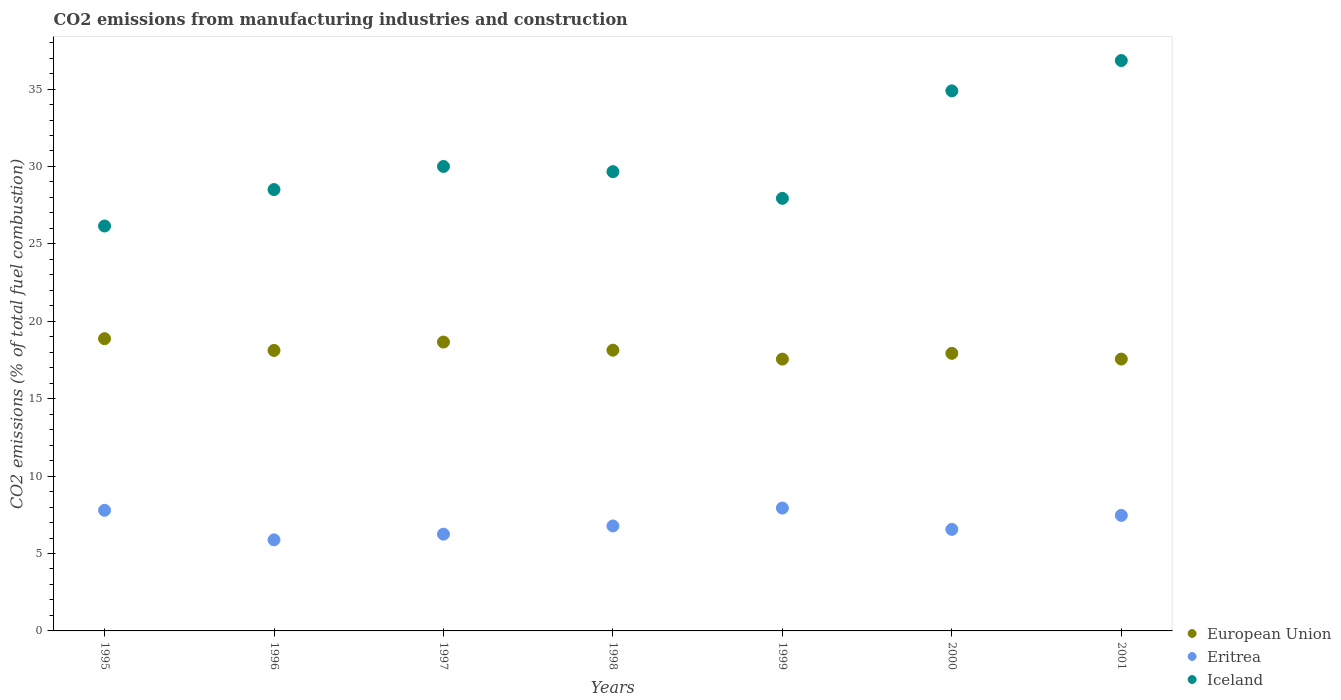Is the number of dotlines equal to the number of legend labels?
Provide a succinct answer. Yes. What is the amount of CO2 emitted in Iceland in 1998?
Make the answer very short. 29.67. Across all years, what is the maximum amount of CO2 emitted in Eritrea?
Keep it short and to the point. 7.94. Across all years, what is the minimum amount of CO2 emitted in European Union?
Your response must be concise. 17.56. In which year was the amount of CO2 emitted in European Union maximum?
Keep it short and to the point. 1995. What is the total amount of CO2 emitted in Iceland in the graph?
Make the answer very short. 213.99. What is the difference between the amount of CO2 emitted in European Union in 1995 and that in 1998?
Ensure brevity in your answer.  0.74. What is the difference between the amount of CO2 emitted in Eritrea in 1995 and the amount of CO2 emitted in Iceland in 2000?
Your answer should be compact. -27.09. What is the average amount of CO2 emitted in Iceland per year?
Keep it short and to the point. 30.57. In the year 1999, what is the difference between the amount of CO2 emitted in European Union and amount of CO2 emitted in Eritrea?
Make the answer very short. 9.62. What is the ratio of the amount of CO2 emitted in European Union in 1997 to that in 2000?
Offer a terse response. 1.04. Is the amount of CO2 emitted in Eritrea in 1997 less than that in 1999?
Offer a terse response. Yes. Is the difference between the amount of CO2 emitted in European Union in 1999 and 2000 greater than the difference between the amount of CO2 emitted in Eritrea in 1999 and 2000?
Keep it short and to the point. No. What is the difference between the highest and the second highest amount of CO2 emitted in Iceland?
Your answer should be very brief. 1.96. What is the difference between the highest and the lowest amount of CO2 emitted in Eritrea?
Ensure brevity in your answer.  2.05. In how many years, is the amount of CO2 emitted in European Union greater than the average amount of CO2 emitted in European Union taken over all years?
Ensure brevity in your answer.  3. Is the sum of the amount of CO2 emitted in Iceland in 1995 and 1998 greater than the maximum amount of CO2 emitted in Eritrea across all years?
Give a very brief answer. Yes. Is the amount of CO2 emitted in European Union strictly greater than the amount of CO2 emitted in Iceland over the years?
Your response must be concise. No. Is the amount of CO2 emitted in Eritrea strictly less than the amount of CO2 emitted in European Union over the years?
Your answer should be compact. Yes. Does the graph contain any zero values?
Give a very brief answer. No. Does the graph contain grids?
Provide a succinct answer. No. What is the title of the graph?
Provide a short and direct response. CO2 emissions from manufacturing industries and construction. What is the label or title of the Y-axis?
Give a very brief answer. CO2 emissions (% of total fuel combustion). What is the CO2 emissions (% of total fuel combustion) in European Union in 1995?
Provide a short and direct response. 18.88. What is the CO2 emissions (% of total fuel combustion) in Eritrea in 1995?
Give a very brief answer. 7.79. What is the CO2 emissions (% of total fuel combustion) in Iceland in 1995?
Give a very brief answer. 26.15. What is the CO2 emissions (% of total fuel combustion) in European Union in 1996?
Ensure brevity in your answer.  18.12. What is the CO2 emissions (% of total fuel combustion) of Eritrea in 1996?
Provide a short and direct response. 5.88. What is the CO2 emissions (% of total fuel combustion) of Iceland in 1996?
Provide a succinct answer. 28.51. What is the CO2 emissions (% of total fuel combustion) in European Union in 1997?
Provide a short and direct response. 18.66. What is the CO2 emissions (% of total fuel combustion) in Eritrea in 1997?
Offer a terse response. 6.25. What is the CO2 emissions (% of total fuel combustion) of Iceland in 1997?
Provide a short and direct response. 30. What is the CO2 emissions (% of total fuel combustion) in European Union in 1998?
Make the answer very short. 18.13. What is the CO2 emissions (% of total fuel combustion) of Eritrea in 1998?
Your answer should be compact. 6.78. What is the CO2 emissions (% of total fuel combustion) in Iceland in 1998?
Offer a very short reply. 29.67. What is the CO2 emissions (% of total fuel combustion) of European Union in 1999?
Provide a succinct answer. 17.56. What is the CO2 emissions (% of total fuel combustion) in Eritrea in 1999?
Keep it short and to the point. 7.94. What is the CO2 emissions (% of total fuel combustion) of Iceland in 1999?
Ensure brevity in your answer.  27.94. What is the CO2 emissions (% of total fuel combustion) in European Union in 2000?
Give a very brief answer. 17.93. What is the CO2 emissions (% of total fuel combustion) of Eritrea in 2000?
Ensure brevity in your answer.  6.56. What is the CO2 emissions (% of total fuel combustion) in Iceland in 2000?
Provide a succinct answer. 34.88. What is the CO2 emissions (% of total fuel combustion) of European Union in 2001?
Your answer should be compact. 17.56. What is the CO2 emissions (% of total fuel combustion) in Eritrea in 2001?
Provide a succinct answer. 7.46. What is the CO2 emissions (% of total fuel combustion) in Iceland in 2001?
Keep it short and to the point. 36.84. Across all years, what is the maximum CO2 emissions (% of total fuel combustion) in European Union?
Provide a succinct answer. 18.88. Across all years, what is the maximum CO2 emissions (% of total fuel combustion) in Eritrea?
Give a very brief answer. 7.94. Across all years, what is the maximum CO2 emissions (% of total fuel combustion) of Iceland?
Provide a succinct answer. 36.84. Across all years, what is the minimum CO2 emissions (% of total fuel combustion) of European Union?
Give a very brief answer. 17.56. Across all years, what is the minimum CO2 emissions (% of total fuel combustion) in Eritrea?
Offer a terse response. 5.88. Across all years, what is the minimum CO2 emissions (% of total fuel combustion) of Iceland?
Keep it short and to the point. 26.15. What is the total CO2 emissions (% of total fuel combustion) of European Union in the graph?
Your answer should be compact. 126.83. What is the total CO2 emissions (% of total fuel combustion) of Eritrea in the graph?
Offer a terse response. 48.66. What is the total CO2 emissions (% of total fuel combustion) in Iceland in the graph?
Your response must be concise. 213.99. What is the difference between the CO2 emissions (% of total fuel combustion) of European Union in 1995 and that in 1996?
Make the answer very short. 0.76. What is the difference between the CO2 emissions (% of total fuel combustion) of Eritrea in 1995 and that in 1996?
Your response must be concise. 1.91. What is the difference between the CO2 emissions (% of total fuel combustion) in Iceland in 1995 and that in 1996?
Your answer should be very brief. -2.35. What is the difference between the CO2 emissions (% of total fuel combustion) of European Union in 1995 and that in 1997?
Ensure brevity in your answer.  0.22. What is the difference between the CO2 emissions (% of total fuel combustion) of Eritrea in 1995 and that in 1997?
Ensure brevity in your answer.  1.54. What is the difference between the CO2 emissions (% of total fuel combustion) of Iceland in 1995 and that in 1997?
Provide a short and direct response. -3.85. What is the difference between the CO2 emissions (% of total fuel combustion) of European Union in 1995 and that in 1998?
Provide a short and direct response. 0.74. What is the difference between the CO2 emissions (% of total fuel combustion) in Eritrea in 1995 and that in 1998?
Provide a succinct answer. 1.01. What is the difference between the CO2 emissions (% of total fuel combustion) of Iceland in 1995 and that in 1998?
Give a very brief answer. -3.51. What is the difference between the CO2 emissions (% of total fuel combustion) of European Union in 1995 and that in 1999?
Provide a short and direct response. 1.32. What is the difference between the CO2 emissions (% of total fuel combustion) of Eritrea in 1995 and that in 1999?
Ensure brevity in your answer.  -0.14. What is the difference between the CO2 emissions (% of total fuel combustion) of Iceland in 1995 and that in 1999?
Your answer should be very brief. -1.79. What is the difference between the CO2 emissions (% of total fuel combustion) of European Union in 1995 and that in 2000?
Offer a very short reply. 0.95. What is the difference between the CO2 emissions (% of total fuel combustion) of Eritrea in 1995 and that in 2000?
Keep it short and to the point. 1.23. What is the difference between the CO2 emissions (% of total fuel combustion) of Iceland in 1995 and that in 2000?
Offer a terse response. -8.73. What is the difference between the CO2 emissions (% of total fuel combustion) in European Union in 1995 and that in 2001?
Your answer should be compact. 1.32. What is the difference between the CO2 emissions (% of total fuel combustion) of Eritrea in 1995 and that in 2001?
Your answer should be very brief. 0.33. What is the difference between the CO2 emissions (% of total fuel combustion) of Iceland in 1995 and that in 2001?
Provide a succinct answer. -10.69. What is the difference between the CO2 emissions (% of total fuel combustion) in European Union in 1996 and that in 1997?
Give a very brief answer. -0.54. What is the difference between the CO2 emissions (% of total fuel combustion) in Eritrea in 1996 and that in 1997?
Provide a short and direct response. -0.37. What is the difference between the CO2 emissions (% of total fuel combustion) of Iceland in 1996 and that in 1997?
Offer a very short reply. -1.49. What is the difference between the CO2 emissions (% of total fuel combustion) in European Union in 1996 and that in 1998?
Your response must be concise. -0.02. What is the difference between the CO2 emissions (% of total fuel combustion) of Eritrea in 1996 and that in 1998?
Provide a short and direct response. -0.9. What is the difference between the CO2 emissions (% of total fuel combustion) in Iceland in 1996 and that in 1998?
Your response must be concise. -1.16. What is the difference between the CO2 emissions (% of total fuel combustion) in European Union in 1996 and that in 1999?
Provide a short and direct response. 0.56. What is the difference between the CO2 emissions (% of total fuel combustion) in Eritrea in 1996 and that in 1999?
Offer a very short reply. -2.05. What is the difference between the CO2 emissions (% of total fuel combustion) in Iceland in 1996 and that in 1999?
Offer a terse response. 0.57. What is the difference between the CO2 emissions (% of total fuel combustion) in European Union in 1996 and that in 2000?
Give a very brief answer. 0.19. What is the difference between the CO2 emissions (% of total fuel combustion) of Eritrea in 1996 and that in 2000?
Give a very brief answer. -0.68. What is the difference between the CO2 emissions (% of total fuel combustion) in Iceland in 1996 and that in 2000?
Keep it short and to the point. -6.38. What is the difference between the CO2 emissions (% of total fuel combustion) in European Union in 1996 and that in 2001?
Ensure brevity in your answer.  0.56. What is the difference between the CO2 emissions (% of total fuel combustion) in Eritrea in 1996 and that in 2001?
Give a very brief answer. -1.58. What is the difference between the CO2 emissions (% of total fuel combustion) in Iceland in 1996 and that in 2001?
Provide a short and direct response. -8.34. What is the difference between the CO2 emissions (% of total fuel combustion) of European Union in 1997 and that in 1998?
Provide a succinct answer. 0.52. What is the difference between the CO2 emissions (% of total fuel combustion) in Eritrea in 1997 and that in 1998?
Offer a very short reply. -0.53. What is the difference between the CO2 emissions (% of total fuel combustion) of Iceland in 1997 and that in 1998?
Your response must be concise. 0.33. What is the difference between the CO2 emissions (% of total fuel combustion) of European Union in 1997 and that in 1999?
Ensure brevity in your answer.  1.1. What is the difference between the CO2 emissions (% of total fuel combustion) of Eritrea in 1997 and that in 1999?
Keep it short and to the point. -1.69. What is the difference between the CO2 emissions (% of total fuel combustion) in Iceland in 1997 and that in 1999?
Keep it short and to the point. 2.06. What is the difference between the CO2 emissions (% of total fuel combustion) of European Union in 1997 and that in 2000?
Make the answer very short. 0.73. What is the difference between the CO2 emissions (% of total fuel combustion) of Eritrea in 1997 and that in 2000?
Provide a succinct answer. -0.31. What is the difference between the CO2 emissions (% of total fuel combustion) in Iceland in 1997 and that in 2000?
Provide a succinct answer. -4.88. What is the difference between the CO2 emissions (% of total fuel combustion) in European Union in 1997 and that in 2001?
Ensure brevity in your answer.  1.1. What is the difference between the CO2 emissions (% of total fuel combustion) in Eritrea in 1997 and that in 2001?
Make the answer very short. -1.21. What is the difference between the CO2 emissions (% of total fuel combustion) of Iceland in 1997 and that in 2001?
Keep it short and to the point. -6.84. What is the difference between the CO2 emissions (% of total fuel combustion) in European Union in 1998 and that in 1999?
Keep it short and to the point. 0.58. What is the difference between the CO2 emissions (% of total fuel combustion) of Eritrea in 1998 and that in 1999?
Provide a short and direct response. -1.16. What is the difference between the CO2 emissions (% of total fuel combustion) in Iceland in 1998 and that in 1999?
Provide a short and direct response. 1.72. What is the difference between the CO2 emissions (% of total fuel combustion) in European Union in 1998 and that in 2000?
Your answer should be compact. 0.2. What is the difference between the CO2 emissions (% of total fuel combustion) of Eritrea in 1998 and that in 2000?
Your answer should be compact. 0.22. What is the difference between the CO2 emissions (% of total fuel combustion) in Iceland in 1998 and that in 2000?
Provide a short and direct response. -5.22. What is the difference between the CO2 emissions (% of total fuel combustion) in European Union in 1998 and that in 2001?
Your response must be concise. 0.57. What is the difference between the CO2 emissions (% of total fuel combustion) of Eritrea in 1998 and that in 2001?
Provide a succinct answer. -0.68. What is the difference between the CO2 emissions (% of total fuel combustion) of Iceland in 1998 and that in 2001?
Your answer should be compact. -7.18. What is the difference between the CO2 emissions (% of total fuel combustion) in European Union in 1999 and that in 2000?
Offer a very short reply. -0.37. What is the difference between the CO2 emissions (% of total fuel combustion) of Eritrea in 1999 and that in 2000?
Ensure brevity in your answer.  1.38. What is the difference between the CO2 emissions (% of total fuel combustion) of Iceland in 1999 and that in 2000?
Keep it short and to the point. -6.94. What is the difference between the CO2 emissions (% of total fuel combustion) in European Union in 1999 and that in 2001?
Keep it short and to the point. -0. What is the difference between the CO2 emissions (% of total fuel combustion) of Eritrea in 1999 and that in 2001?
Ensure brevity in your answer.  0.47. What is the difference between the CO2 emissions (% of total fuel combustion) in Iceland in 1999 and that in 2001?
Your response must be concise. -8.9. What is the difference between the CO2 emissions (% of total fuel combustion) in European Union in 2000 and that in 2001?
Make the answer very short. 0.37. What is the difference between the CO2 emissions (% of total fuel combustion) in Eritrea in 2000 and that in 2001?
Make the answer very short. -0.91. What is the difference between the CO2 emissions (% of total fuel combustion) in Iceland in 2000 and that in 2001?
Give a very brief answer. -1.96. What is the difference between the CO2 emissions (% of total fuel combustion) in European Union in 1995 and the CO2 emissions (% of total fuel combustion) in Eritrea in 1996?
Your answer should be very brief. 12.99. What is the difference between the CO2 emissions (% of total fuel combustion) in European Union in 1995 and the CO2 emissions (% of total fuel combustion) in Iceland in 1996?
Offer a very short reply. -9.63. What is the difference between the CO2 emissions (% of total fuel combustion) in Eritrea in 1995 and the CO2 emissions (% of total fuel combustion) in Iceland in 1996?
Offer a very short reply. -20.71. What is the difference between the CO2 emissions (% of total fuel combustion) in European Union in 1995 and the CO2 emissions (% of total fuel combustion) in Eritrea in 1997?
Provide a short and direct response. 12.63. What is the difference between the CO2 emissions (% of total fuel combustion) in European Union in 1995 and the CO2 emissions (% of total fuel combustion) in Iceland in 1997?
Provide a succinct answer. -11.12. What is the difference between the CO2 emissions (% of total fuel combustion) in Eritrea in 1995 and the CO2 emissions (% of total fuel combustion) in Iceland in 1997?
Offer a terse response. -22.21. What is the difference between the CO2 emissions (% of total fuel combustion) in European Union in 1995 and the CO2 emissions (% of total fuel combustion) in Eritrea in 1998?
Ensure brevity in your answer.  12.1. What is the difference between the CO2 emissions (% of total fuel combustion) of European Union in 1995 and the CO2 emissions (% of total fuel combustion) of Iceland in 1998?
Offer a terse response. -10.79. What is the difference between the CO2 emissions (% of total fuel combustion) in Eritrea in 1995 and the CO2 emissions (% of total fuel combustion) in Iceland in 1998?
Offer a very short reply. -21.87. What is the difference between the CO2 emissions (% of total fuel combustion) in European Union in 1995 and the CO2 emissions (% of total fuel combustion) in Eritrea in 1999?
Your answer should be very brief. 10.94. What is the difference between the CO2 emissions (% of total fuel combustion) of European Union in 1995 and the CO2 emissions (% of total fuel combustion) of Iceland in 1999?
Keep it short and to the point. -9.07. What is the difference between the CO2 emissions (% of total fuel combustion) of Eritrea in 1995 and the CO2 emissions (% of total fuel combustion) of Iceland in 1999?
Ensure brevity in your answer.  -20.15. What is the difference between the CO2 emissions (% of total fuel combustion) in European Union in 1995 and the CO2 emissions (% of total fuel combustion) in Eritrea in 2000?
Your answer should be very brief. 12.32. What is the difference between the CO2 emissions (% of total fuel combustion) in European Union in 1995 and the CO2 emissions (% of total fuel combustion) in Iceland in 2000?
Your answer should be compact. -16.01. What is the difference between the CO2 emissions (% of total fuel combustion) of Eritrea in 1995 and the CO2 emissions (% of total fuel combustion) of Iceland in 2000?
Provide a short and direct response. -27.09. What is the difference between the CO2 emissions (% of total fuel combustion) of European Union in 1995 and the CO2 emissions (% of total fuel combustion) of Eritrea in 2001?
Offer a terse response. 11.41. What is the difference between the CO2 emissions (% of total fuel combustion) in European Union in 1995 and the CO2 emissions (% of total fuel combustion) in Iceland in 2001?
Make the answer very short. -17.97. What is the difference between the CO2 emissions (% of total fuel combustion) of Eritrea in 1995 and the CO2 emissions (% of total fuel combustion) of Iceland in 2001?
Offer a terse response. -29.05. What is the difference between the CO2 emissions (% of total fuel combustion) of European Union in 1996 and the CO2 emissions (% of total fuel combustion) of Eritrea in 1997?
Provide a short and direct response. 11.87. What is the difference between the CO2 emissions (% of total fuel combustion) in European Union in 1996 and the CO2 emissions (% of total fuel combustion) in Iceland in 1997?
Keep it short and to the point. -11.88. What is the difference between the CO2 emissions (% of total fuel combustion) of Eritrea in 1996 and the CO2 emissions (% of total fuel combustion) of Iceland in 1997?
Give a very brief answer. -24.12. What is the difference between the CO2 emissions (% of total fuel combustion) in European Union in 1996 and the CO2 emissions (% of total fuel combustion) in Eritrea in 1998?
Provide a short and direct response. 11.34. What is the difference between the CO2 emissions (% of total fuel combustion) in European Union in 1996 and the CO2 emissions (% of total fuel combustion) in Iceland in 1998?
Your answer should be very brief. -11.55. What is the difference between the CO2 emissions (% of total fuel combustion) of Eritrea in 1996 and the CO2 emissions (% of total fuel combustion) of Iceland in 1998?
Your response must be concise. -23.78. What is the difference between the CO2 emissions (% of total fuel combustion) in European Union in 1996 and the CO2 emissions (% of total fuel combustion) in Eritrea in 1999?
Your answer should be compact. 10.18. What is the difference between the CO2 emissions (% of total fuel combustion) in European Union in 1996 and the CO2 emissions (% of total fuel combustion) in Iceland in 1999?
Make the answer very short. -9.82. What is the difference between the CO2 emissions (% of total fuel combustion) of Eritrea in 1996 and the CO2 emissions (% of total fuel combustion) of Iceland in 1999?
Offer a very short reply. -22.06. What is the difference between the CO2 emissions (% of total fuel combustion) of European Union in 1996 and the CO2 emissions (% of total fuel combustion) of Eritrea in 2000?
Keep it short and to the point. 11.56. What is the difference between the CO2 emissions (% of total fuel combustion) of European Union in 1996 and the CO2 emissions (% of total fuel combustion) of Iceland in 2000?
Keep it short and to the point. -16.77. What is the difference between the CO2 emissions (% of total fuel combustion) in Eritrea in 1996 and the CO2 emissions (% of total fuel combustion) in Iceland in 2000?
Make the answer very short. -29. What is the difference between the CO2 emissions (% of total fuel combustion) of European Union in 1996 and the CO2 emissions (% of total fuel combustion) of Eritrea in 2001?
Give a very brief answer. 10.65. What is the difference between the CO2 emissions (% of total fuel combustion) of European Union in 1996 and the CO2 emissions (% of total fuel combustion) of Iceland in 2001?
Keep it short and to the point. -18.73. What is the difference between the CO2 emissions (% of total fuel combustion) in Eritrea in 1996 and the CO2 emissions (% of total fuel combustion) in Iceland in 2001?
Ensure brevity in your answer.  -30.96. What is the difference between the CO2 emissions (% of total fuel combustion) of European Union in 1997 and the CO2 emissions (% of total fuel combustion) of Eritrea in 1998?
Your response must be concise. 11.88. What is the difference between the CO2 emissions (% of total fuel combustion) in European Union in 1997 and the CO2 emissions (% of total fuel combustion) in Iceland in 1998?
Give a very brief answer. -11.01. What is the difference between the CO2 emissions (% of total fuel combustion) of Eritrea in 1997 and the CO2 emissions (% of total fuel combustion) of Iceland in 1998?
Give a very brief answer. -23.42. What is the difference between the CO2 emissions (% of total fuel combustion) of European Union in 1997 and the CO2 emissions (% of total fuel combustion) of Eritrea in 1999?
Your answer should be very brief. 10.72. What is the difference between the CO2 emissions (% of total fuel combustion) in European Union in 1997 and the CO2 emissions (% of total fuel combustion) in Iceland in 1999?
Offer a very short reply. -9.28. What is the difference between the CO2 emissions (% of total fuel combustion) in Eritrea in 1997 and the CO2 emissions (% of total fuel combustion) in Iceland in 1999?
Your answer should be compact. -21.69. What is the difference between the CO2 emissions (% of total fuel combustion) of European Union in 1997 and the CO2 emissions (% of total fuel combustion) of Eritrea in 2000?
Ensure brevity in your answer.  12.1. What is the difference between the CO2 emissions (% of total fuel combustion) in European Union in 1997 and the CO2 emissions (% of total fuel combustion) in Iceland in 2000?
Provide a short and direct response. -16.23. What is the difference between the CO2 emissions (% of total fuel combustion) of Eritrea in 1997 and the CO2 emissions (% of total fuel combustion) of Iceland in 2000?
Offer a very short reply. -28.63. What is the difference between the CO2 emissions (% of total fuel combustion) of European Union in 1997 and the CO2 emissions (% of total fuel combustion) of Eritrea in 2001?
Give a very brief answer. 11.2. What is the difference between the CO2 emissions (% of total fuel combustion) in European Union in 1997 and the CO2 emissions (% of total fuel combustion) in Iceland in 2001?
Offer a very short reply. -18.18. What is the difference between the CO2 emissions (% of total fuel combustion) in Eritrea in 1997 and the CO2 emissions (% of total fuel combustion) in Iceland in 2001?
Your response must be concise. -30.59. What is the difference between the CO2 emissions (% of total fuel combustion) of European Union in 1998 and the CO2 emissions (% of total fuel combustion) of Eritrea in 1999?
Your answer should be compact. 10.2. What is the difference between the CO2 emissions (% of total fuel combustion) in European Union in 1998 and the CO2 emissions (% of total fuel combustion) in Iceland in 1999?
Provide a short and direct response. -9.81. What is the difference between the CO2 emissions (% of total fuel combustion) of Eritrea in 1998 and the CO2 emissions (% of total fuel combustion) of Iceland in 1999?
Provide a succinct answer. -21.16. What is the difference between the CO2 emissions (% of total fuel combustion) of European Union in 1998 and the CO2 emissions (% of total fuel combustion) of Eritrea in 2000?
Provide a short and direct response. 11.58. What is the difference between the CO2 emissions (% of total fuel combustion) in European Union in 1998 and the CO2 emissions (% of total fuel combustion) in Iceland in 2000?
Provide a short and direct response. -16.75. What is the difference between the CO2 emissions (% of total fuel combustion) of Eritrea in 1998 and the CO2 emissions (% of total fuel combustion) of Iceland in 2000?
Your response must be concise. -28.1. What is the difference between the CO2 emissions (% of total fuel combustion) in European Union in 1998 and the CO2 emissions (% of total fuel combustion) in Eritrea in 2001?
Keep it short and to the point. 10.67. What is the difference between the CO2 emissions (% of total fuel combustion) of European Union in 1998 and the CO2 emissions (% of total fuel combustion) of Iceland in 2001?
Make the answer very short. -18.71. What is the difference between the CO2 emissions (% of total fuel combustion) of Eritrea in 1998 and the CO2 emissions (% of total fuel combustion) of Iceland in 2001?
Your answer should be compact. -30.06. What is the difference between the CO2 emissions (% of total fuel combustion) of European Union in 1999 and the CO2 emissions (% of total fuel combustion) of Eritrea in 2000?
Your answer should be compact. 11. What is the difference between the CO2 emissions (% of total fuel combustion) in European Union in 1999 and the CO2 emissions (% of total fuel combustion) in Iceland in 2000?
Give a very brief answer. -17.33. What is the difference between the CO2 emissions (% of total fuel combustion) of Eritrea in 1999 and the CO2 emissions (% of total fuel combustion) of Iceland in 2000?
Provide a succinct answer. -26.95. What is the difference between the CO2 emissions (% of total fuel combustion) of European Union in 1999 and the CO2 emissions (% of total fuel combustion) of Eritrea in 2001?
Make the answer very short. 10.09. What is the difference between the CO2 emissions (% of total fuel combustion) of European Union in 1999 and the CO2 emissions (% of total fuel combustion) of Iceland in 2001?
Offer a very short reply. -19.29. What is the difference between the CO2 emissions (% of total fuel combustion) of Eritrea in 1999 and the CO2 emissions (% of total fuel combustion) of Iceland in 2001?
Provide a short and direct response. -28.91. What is the difference between the CO2 emissions (% of total fuel combustion) in European Union in 2000 and the CO2 emissions (% of total fuel combustion) in Eritrea in 2001?
Your answer should be compact. 10.47. What is the difference between the CO2 emissions (% of total fuel combustion) of European Union in 2000 and the CO2 emissions (% of total fuel combustion) of Iceland in 2001?
Your answer should be compact. -18.91. What is the difference between the CO2 emissions (% of total fuel combustion) in Eritrea in 2000 and the CO2 emissions (% of total fuel combustion) in Iceland in 2001?
Keep it short and to the point. -30.28. What is the average CO2 emissions (% of total fuel combustion) of European Union per year?
Give a very brief answer. 18.12. What is the average CO2 emissions (% of total fuel combustion) in Eritrea per year?
Make the answer very short. 6.95. What is the average CO2 emissions (% of total fuel combustion) in Iceland per year?
Give a very brief answer. 30.57. In the year 1995, what is the difference between the CO2 emissions (% of total fuel combustion) in European Union and CO2 emissions (% of total fuel combustion) in Eritrea?
Make the answer very short. 11.08. In the year 1995, what is the difference between the CO2 emissions (% of total fuel combustion) of European Union and CO2 emissions (% of total fuel combustion) of Iceland?
Offer a terse response. -7.28. In the year 1995, what is the difference between the CO2 emissions (% of total fuel combustion) in Eritrea and CO2 emissions (% of total fuel combustion) in Iceland?
Keep it short and to the point. -18.36. In the year 1996, what is the difference between the CO2 emissions (% of total fuel combustion) in European Union and CO2 emissions (% of total fuel combustion) in Eritrea?
Offer a terse response. 12.23. In the year 1996, what is the difference between the CO2 emissions (% of total fuel combustion) of European Union and CO2 emissions (% of total fuel combustion) of Iceland?
Your answer should be very brief. -10.39. In the year 1996, what is the difference between the CO2 emissions (% of total fuel combustion) of Eritrea and CO2 emissions (% of total fuel combustion) of Iceland?
Your response must be concise. -22.62. In the year 1997, what is the difference between the CO2 emissions (% of total fuel combustion) in European Union and CO2 emissions (% of total fuel combustion) in Eritrea?
Keep it short and to the point. 12.41. In the year 1997, what is the difference between the CO2 emissions (% of total fuel combustion) of European Union and CO2 emissions (% of total fuel combustion) of Iceland?
Make the answer very short. -11.34. In the year 1997, what is the difference between the CO2 emissions (% of total fuel combustion) in Eritrea and CO2 emissions (% of total fuel combustion) in Iceland?
Your answer should be very brief. -23.75. In the year 1998, what is the difference between the CO2 emissions (% of total fuel combustion) in European Union and CO2 emissions (% of total fuel combustion) in Eritrea?
Keep it short and to the point. 11.35. In the year 1998, what is the difference between the CO2 emissions (% of total fuel combustion) of European Union and CO2 emissions (% of total fuel combustion) of Iceland?
Keep it short and to the point. -11.53. In the year 1998, what is the difference between the CO2 emissions (% of total fuel combustion) of Eritrea and CO2 emissions (% of total fuel combustion) of Iceland?
Your answer should be compact. -22.89. In the year 1999, what is the difference between the CO2 emissions (% of total fuel combustion) in European Union and CO2 emissions (% of total fuel combustion) in Eritrea?
Provide a succinct answer. 9.62. In the year 1999, what is the difference between the CO2 emissions (% of total fuel combustion) in European Union and CO2 emissions (% of total fuel combustion) in Iceland?
Offer a terse response. -10.39. In the year 1999, what is the difference between the CO2 emissions (% of total fuel combustion) in Eritrea and CO2 emissions (% of total fuel combustion) in Iceland?
Offer a very short reply. -20. In the year 2000, what is the difference between the CO2 emissions (% of total fuel combustion) of European Union and CO2 emissions (% of total fuel combustion) of Eritrea?
Give a very brief answer. 11.37. In the year 2000, what is the difference between the CO2 emissions (% of total fuel combustion) of European Union and CO2 emissions (% of total fuel combustion) of Iceland?
Offer a very short reply. -16.96. In the year 2000, what is the difference between the CO2 emissions (% of total fuel combustion) in Eritrea and CO2 emissions (% of total fuel combustion) in Iceland?
Your response must be concise. -28.33. In the year 2001, what is the difference between the CO2 emissions (% of total fuel combustion) of European Union and CO2 emissions (% of total fuel combustion) of Eritrea?
Make the answer very short. 10.1. In the year 2001, what is the difference between the CO2 emissions (% of total fuel combustion) of European Union and CO2 emissions (% of total fuel combustion) of Iceland?
Your answer should be compact. -19.28. In the year 2001, what is the difference between the CO2 emissions (% of total fuel combustion) of Eritrea and CO2 emissions (% of total fuel combustion) of Iceland?
Keep it short and to the point. -29.38. What is the ratio of the CO2 emissions (% of total fuel combustion) in European Union in 1995 to that in 1996?
Give a very brief answer. 1.04. What is the ratio of the CO2 emissions (% of total fuel combustion) in Eritrea in 1995 to that in 1996?
Keep it short and to the point. 1.32. What is the ratio of the CO2 emissions (% of total fuel combustion) of Iceland in 1995 to that in 1996?
Keep it short and to the point. 0.92. What is the ratio of the CO2 emissions (% of total fuel combustion) in European Union in 1995 to that in 1997?
Your answer should be very brief. 1.01. What is the ratio of the CO2 emissions (% of total fuel combustion) in Eritrea in 1995 to that in 1997?
Offer a very short reply. 1.25. What is the ratio of the CO2 emissions (% of total fuel combustion) of Iceland in 1995 to that in 1997?
Keep it short and to the point. 0.87. What is the ratio of the CO2 emissions (% of total fuel combustion) in European Union in 1995 to that in 1998?
Provide a short and direct response. 1.04. What is the ratio of the CO2 emissions (% of total fuel combustion) of Eritrea in 1995 to that in 1998?
Provide a short and direct response. 1.15. What is the ratio of the CO2 emissions (% of total fuel combustion) in Iceland in 1995 to that in 1998?
Give a very brief answer. 0.88. What is the ratio of the CO2 emissions (% of total fuel combustion) of European Union in 1995 to that in 1999?
Your response must be concise. 1.08. What is the ratio of the CO2 emissions (% of total fuel combustion) of Eritrea in 1995 to that in 1999?
Ensure brevity in your answer.  0.98. What is the ratio of the CO2 emissions (% of total fuel combustion) in Iceland in 1995 to that in 1999?
Make the answer very short. 0.94. What is the ratio of the CO2 emissions (% of total fuel combustion) in European Union in 1995 to that in 2000?
Offer a very short reply. 1.05. What is the ratio of the CO2 emissions (% of total fuel combustion) in Eritrea in 1995 to that in 2000?
Offer a terse response. 1.19. What is the ratio of the CO2 emissions (% of total fuel combustion) in Iceland in 1995 to that in 2000?
Provide a succinct answer. 0.75. What is the ratio of the CO2 emissions (% of total fuel combustion) of European Union in 1995 to that in 2001?
Your answer should be very brief. 1.07. What is the ratio of the CO2 emissions (% of total fuel combustion) in Eritrea in 1995 to that in 2001?
Your answer should be compact. 1.04. What is the ratio of the CO2 emissions (% of total fuel combustion) in Iceland in 1995 to that in 2001?
Provide a succinct answer. 0.71. What is the ratio of the CO2 emissions (% of total fuel combustion) of Iceland in 1996 to that in 1997?
Provide a succinct answer. 0.95. What is the ratio of the CO2 emissions (% of total fuel combustion) in European Union in 1996 to that in 1998?
Ensure brevity in your answer.  1. What is the ratio of the CO2 emissions (% of total fuel combustion) in Eritrea in 1996 to that in 1998?
Ensure brevity in your answer.  0.87. What is the ratio of the CO2 emissions (% of total fuel combustion) in European Union in 1996 to that in 1999?
Offer a terse response. 1.03. What is the ratio of the CO2 emissions (% of total fuel combustion) of Eritrea in 1996 to that in 1999?
Ensure brevity in your answer.  0.74. What is the ratio of the CO2 emissions (% of total fuel combustion) of Iceland in 1996 to that in 1999?
Keep it short and to the point. 1.02. What is the ratio of the CO2 emissions (% of total fuel combustion) in European Union in 1996 to that in 2000?
Your response must be concise. 1.01. What is the ratio of the CO2 emissions (% of total fuel combustion) of Eritrea in 1996 to that in 2000?
Your answer should be compact. 0.9. What is the ratio of the CO2 emissions (% of total fuel combustion) in Iceland in 1996 to that in 2000?
Give a very brief answer. 0.82. What is the ratio of the CO2 emissions (% of total fuel combustion) of European Union in 1996 to that in 2001?
Ensure brevity in your answer.  1.03. What is the ratio of the CO2 emissions (% of total fuel combustion) of Eritrea in 1996 to that in 2001?
Provide a short and direct response. 0.79. What is the ratio of the CO2 emissions (% of total fuel combustion) in Iceland in 1996 to that in 2001?
Your answer should be very brief. 0.77. What is the ratio of the CO2 emissions (% of total fuel combustion) in European Union in 1997 to that in 1998?
Keep it short and to the point. 1.03. What is the ratio of the CO2 emissions (% of total fuel combustion) in Eritrea in 1997 to that in 1998?
Your response must be concise. 0.92. What is the ratio of the CO2 emissions (% of total fuel combustion) of Iceland in 1997 to that in 1998?
Give a very brief answer. 1.01. What is the ratio of the CO2 emissions (% of total fuel combustion) of European Union in 1997 to that in 1999?
Offer a very short reply. 1.06. What is the ratio of the CO2 emissions (% of total fuel combustion) of Eritrea in 1997 to that in 1999?
Make the answer very short. 0.79. What is the ratio of the CO2 emissions (% of total fuel combustion) in Iceland in 1997 to that in 1999?
Keep it short and to the point. 1.07. What is the ratio of the CO2 emissions (% of total fuel combustion) in European Union in 1997 to that in 2000?
Make the answer very short. 1.04. What is the ratio of the CO2 emissions (% of total fuel combustion) of Eritrea in 1997 to that in 2000?
Provide a short and direct response. 0.95. What is the ratio of the CO2 emissions (% of total fuel combustion) in Iceland in 1997 to that in 2000?
Your answer should be very brief. 0.86. What is the ratio of the CO2 emissions (% of total fuel combustion) of European Union in 1997 to that in 2001?
Your response must be concise. 1.06. What is the ratio of the CO2 emissions (% of total fuel combustion) of Eritrea in 1997 to that in 2001?
Offer a terse response. 0.84. What is the ratio of the CO2 emissions (% of total fuel combustion) of Iceland in 1997 to that in 2001?
Your answer should be compact. 0.81. What is the ratio of the CO2 emissions (% of total fuel combustion) of European Union in 1998 to that in 1999?
Your answer should be compact. 1.03. What is the ratio of the CO2 emissions (% of total fuel combustion) of Eritrea in 1998 to that in 1999?
Your answer should be compact. 0.85. What is the ratio of the CO2 emissions (% of total fuel combustion) of Iceland in 1998 to that in 1999?
Your response must be concise. 1.06. What is the ratio of the CO2 emissions (% of total fuel combustion) in European Union in 1998 to that in 2000?
Keep it short and to the point. 1.01. What is the ratio of the CO2 emissions (% of total fuel combustion) of Eritrea in 1998 to that in 2000?
Provide a short and direct response. 1.03. What is the ratio of the CO2 emissions (% of total fuel combustion) of Iceland in 1998 to that in 2000?
Your answer should be very brief. 0.85. What is the ratio of the CO2 emissions (% of total fuel combustion) in European Union in 1998 to that in 2001?
Ensure brevity in your answer.  1.03. What is the ratio of the CO2 emissions (% of total fuel combustion) in Eritrea in 1998 to that in 2001?
Provide a succinct answer. 0.91. What is the ratio of the CO2 emissions (% of total fuel combustion) in Iceland in 1998 to that in 2001?
Provide a succinct answer. 0.81. What is the ratio of the CO2 emissions (% of total fuel combustion) of European Union in 1999 to that in 2000?
Your response must be concise. 0.98. What is the ratio of the CO2 emissions (% of total fuel combustion) of Eritrea in 1999 to that in 2000?
Provide a short and direct response. 1.21. What is the ratio of the CO2 emissions (% of total fuel combustion) of Iceland in 1999 to that in 2000?
Offer a terse response. 0.8. What is the ratio of the CO2 emissions (% of total fuel combustion) of Eritrea in 1999 to that in 2001?
Your response must be concise. 1.06. What is the ratio of the CO2 emissions (% of total fuel combustion) in Iceland in 1999 to that in 2001?
Your answer should be very brief. 0.76. What is the ratio of the CO2 emissions (% of total fuel combustion) of European Union in 2000 to that in 2001?
Make the answer very short. 1.02. What is the ratio of the CO2 emissions (% of total fuel combustion) in Eritrea in 2000 to that in 2001?
Provide a short and direct response. 0.88. What is the ratio of the CO2 emissions (% of total fuel combustion) in Iceland in 2000 to that in 2001?
Ensure brevity in your answer.  0.95. What is the difference between the highest and the second highest CO2 emissions (% of total fuel combustion) in European Union?
Make the answer very short. 0.22. What is the difference between the highest and the second highest CO2 emissions (% of total fuel combustion) of Eritrea?
Offer a very short reply. 0.14. What is the difference between the highest and the second highest CO2 emissions (% of total fuel combustion) of Iceland?
Your answer should be very brief. 1.96. What is the difference between the highest and the lowest CO2 emissions (% of total fuel combustion) of European Union?
Offer a very short reply. 1.32. What is the difference between the highest and the lowest CO2 emissions (% of total fuel combustion) in Eritrea?
Keep it short and to the point. 2.05. What is the difference between the highest and the lowest CO2 emissions (% of total fuel combustion) of Iceland?
Offer a very short reply. 10.69. 